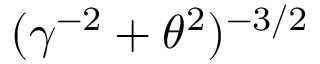Convert formula to latex. <formula><loc_0><loc_0><loc_500><loc_500>( \gamma ^ { - 2 } + \theta ^ { 2 } ) ^ { - { 3 / 2 } }</formula> 